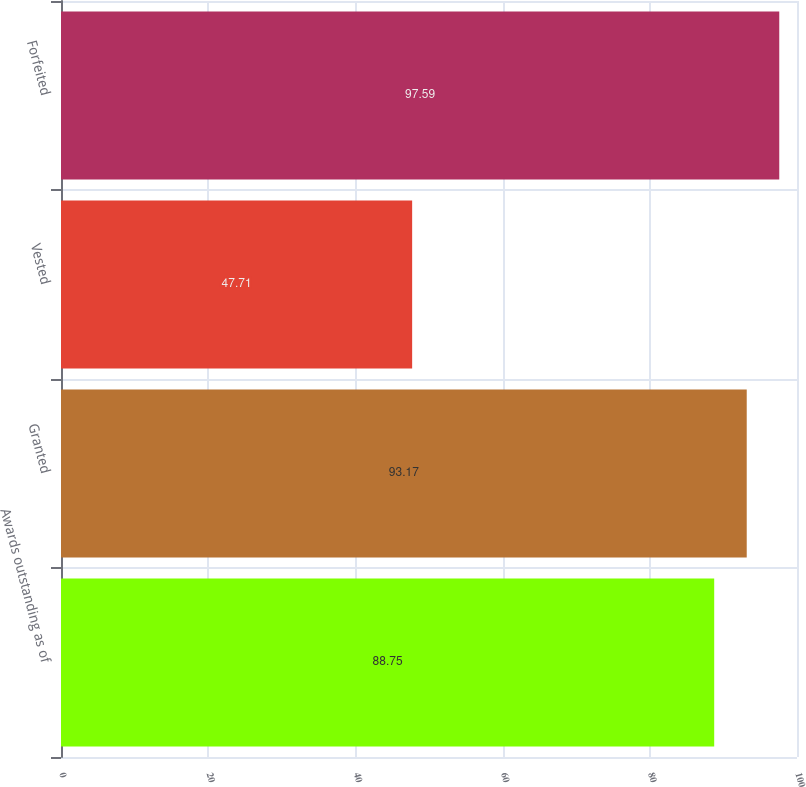<chart> <loc_0><loc_0><loc_500><loc_500><bar_chart><fcel>Awards outstanding as of<fcel>Granted<fcel>Vested<fcel>Forfeited<nl><fcel>88.75<fcel>93.17<fcel>47.71<fcel>97.59<nl></chart> 